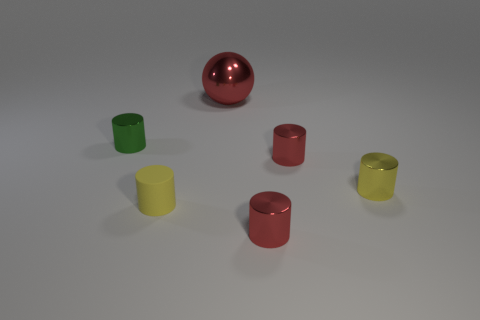Subtract all green metallic cylinders. How many cylinders are left? 4 Subtract all green cylinders. How many cylinders are left? 4 Subtract all cyan cylinders. Subtract all red balls. How many cylinders are left? 5 Add 3 big brown cylinders. How many objects exist? 9 Subtract all spheres. How many objects are left? 5 Add 2 brown things. How many brown things exist? 2 Subtract 0 purple cubes. How many objects are left? 6 Subtract all tiny blue metallic cylinders. Subtract all tiny yellow rubber cylinders. How many objects are left? 5 Add 1 green shiny cylinders. How many green shiny cylinders are left? 2 